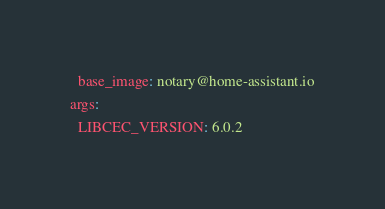<code> <loc_0><loc_0><loc_500><loc_500><_YAML_>  base_image: notary@home-assistant.io
args:
  LIBCEC_VERSION: 6.0.2
</code> 